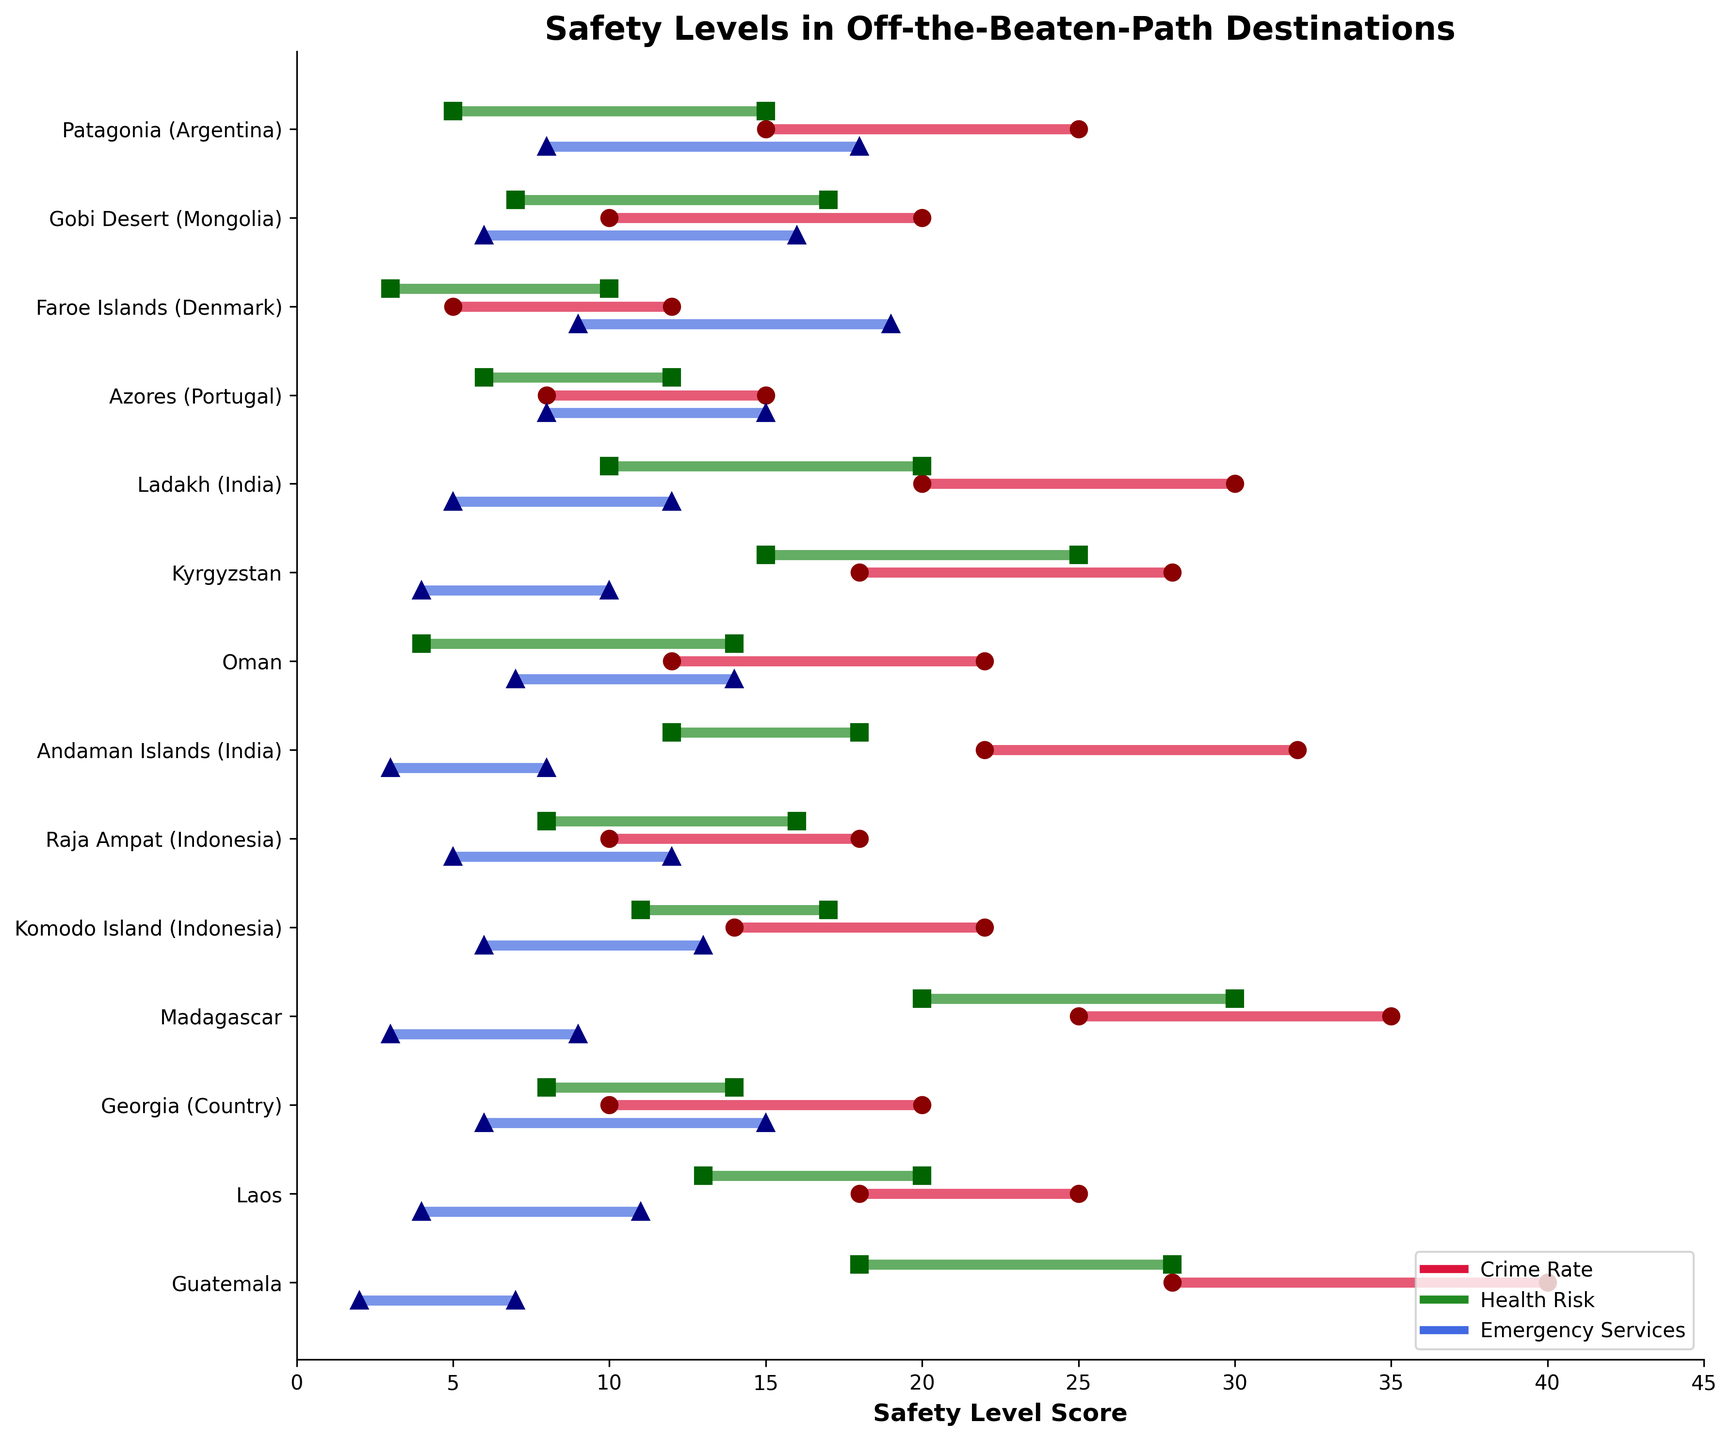What is the title of the plot? The title of the plot is usually displayed at the top of the chart, which describes the main objective of the plot.
Answer: Safety Levels in Off-the-Beaten-Path Destinations Which destination has the highest crime rate range? The destination with the highest crime rate range is the one with the longest red line in the Crime Rate section. From the plot, it's 'Guatemala' with a range from 28 to 40.
Answer: Guatemala How does the health risk in the Faroe Islands compare to that in Madagascar? To compare the health risk, we look at the green lines. The Faroe Islands have a health risk range of 3 to 10, while Madagascar has a range of 20 to 30. Clearly, Madagascar has a higher health risk than the Faroe Islands.
Answer: Madagascar has a higher health risk than the Faroe Islands What are the emergency service levels for Kyrgyzstan? To find this, we check the blue lines that correspond to Kyrgyzstan. The emergency service level range is from 4 to 10.
Answer: 4 to 10 Which destination has the smallest range for health risks, and what is that range? To find the smallest range for health risks, we look for the shortest green line in the Health Risk section. For the Faroe Islands, the health risk range is from 3 to 10, making it the smallest range.
Answer: The Faroe Islands with a range of 3 to 10 What is the average crime rate range for Komodo Island and Laos? First, we find the crime rate ranges: Komodo Island is 14-22, and Laos is 18-25. Then, calculate the midpoint for each: (14+22)/2 = 18 for Komodo Island and (18+25)/2 = 21.5 for Laos. Lastly, average these midpoints: (18 + 21.5) / 2 = 19.75.
Answer: 19.75 Is there any destination where the emergency service high value is less than 10? Check the blue triangles marking the upper bounds for emergency service values. The Andaman Islands and Madagascar have their emergency service highest points below 10, specifically at 8 and 9, respectively.
Answer: Yes, Andaman Islands and Madagascar How does the crime rate of Oman compare to that of Raja Ampat? For this, check the red lines for Oman and Raja Ampat. Oman's range is 12-22, while Raja Ampat's range is 10-18. Oman has a generally higher or equal crime rate compared to Raja Ampat.
Answer: Oman has a generally higher crime rate Among all destinations, which one has the greatest range in health risks? The greatest range in health risks will be the longest green line. Madagascar, with a health risk range from 20 to 30, has the widest spread.
Answer: Madagascar with a range of 10 points (20–30) What are the emergency service levels for destinations in India? Look for the blue lines corresponding to any destination in India. Ladakh ranges from 5 to 12, while the Andaman Islands range from 3 to 8.
Answer: Ladakh: 5-12, Andaman Islands: 3-8 